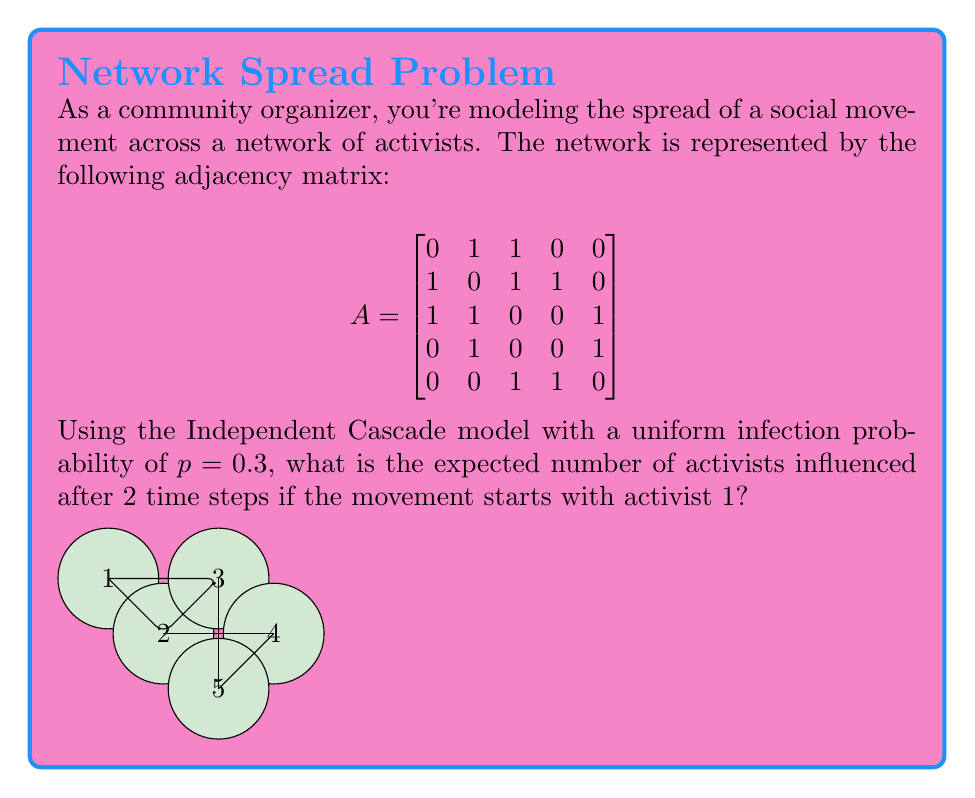Can you answer this question? Let's approach this step-by-step:

1) In the Independent Cascade model, each activated node tries to activate its neighbors with probability $p$ in each time step.

2) At time $t=0$, only activist 1 is influenced.

3) At $t=1$, activist 1 tries to influence activists 2 and 3:
   - Probability of influencing 2: $0.3$
   - Probability of influencing 3: $0.3$
   - Expected number of new activists at $t=1$: $0.3 + 0.3 = 0.6$

4) At $t=2$, we have three possible scenarios:
   a) Only 1 is active (prob: $0.49$)
   b) 1 and 2 are active (prob: $0.21$)
   c) 1 and 3 are active (prob: $0.21$)
   d) 1, 2, and 3 are active (prob: $0.09$)

5) For each scenario at $t=2$:
   a) 1 tries again to influence 2 and 3: $2 * 0.3 = 0.6$
   b) 1 tries for 3, 2 tries for 3 and 4: $0.3 + 0.3 + 0.3 = 0.9$
   c) 1 tries for 2, 3 tries for 2, 4, and 5: $0.3 + 0.3 + 0.3 + 0.3 = 1.2$
   d) 2 tries for 4, 3 tries for 4 and 5: $0.3 + 0.3 + 0.3 = 0.9$

6) Expected number of new activists at $t=2$:
   $0.49 * 0.6 + 0.21 * 0.9 + 0.21 * 1.2 + 0.09 * 0.9 = 0.813$

7) Total expected number of activists after 2 time steps:
   $1 + 0.6 + 0.813 = 2.413$
Answer: 2.413 